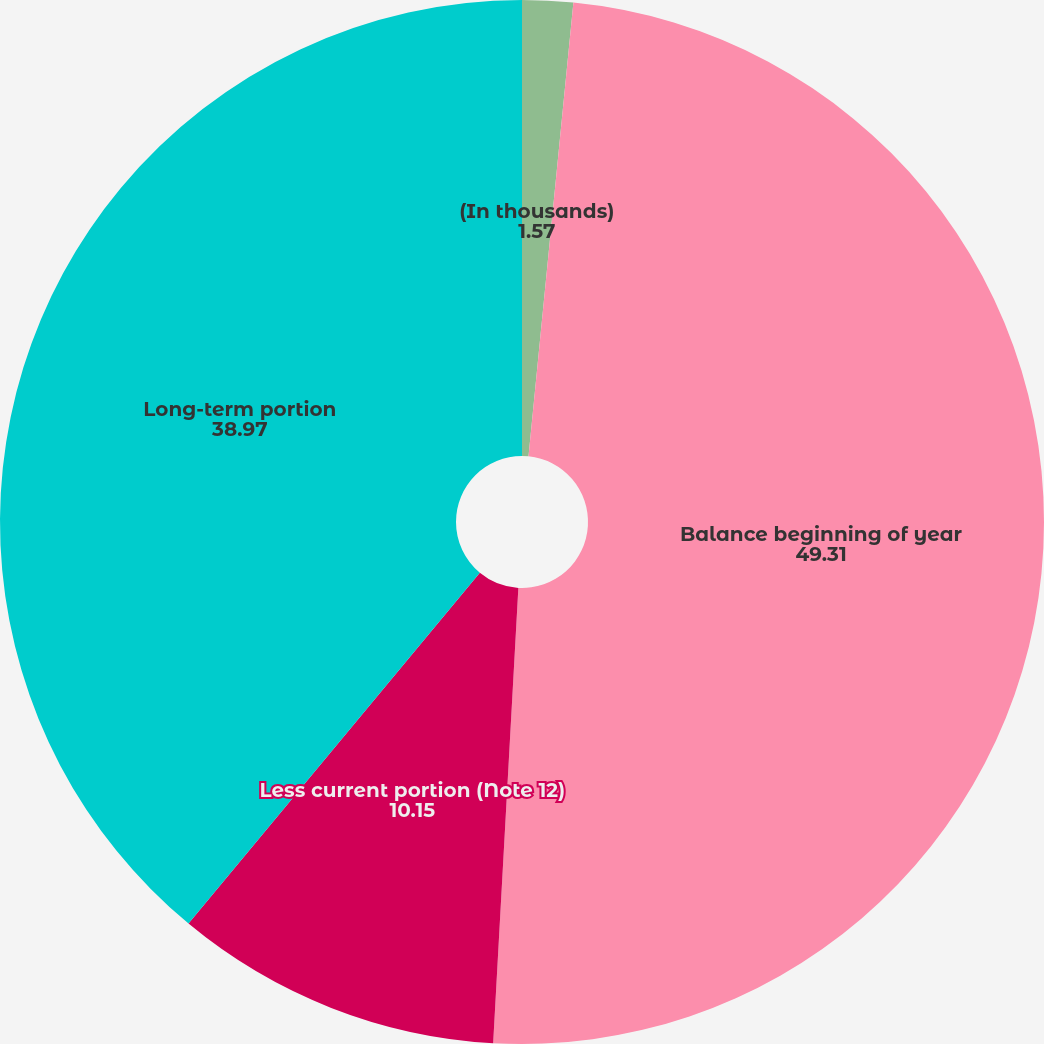Convert chart to OTSL. <chart><loc_0><loc_0><loc_500><loc_500><pie_chart><fcel>(In thousands)<fcel>Balance beginning of year<fcel>Less current portion (Note 12)<fcel>Long-term portion<nl><fcel>1.57%<fcel>49.31%<fcel>10.15%<fcel>38.97%<nl></chart> 